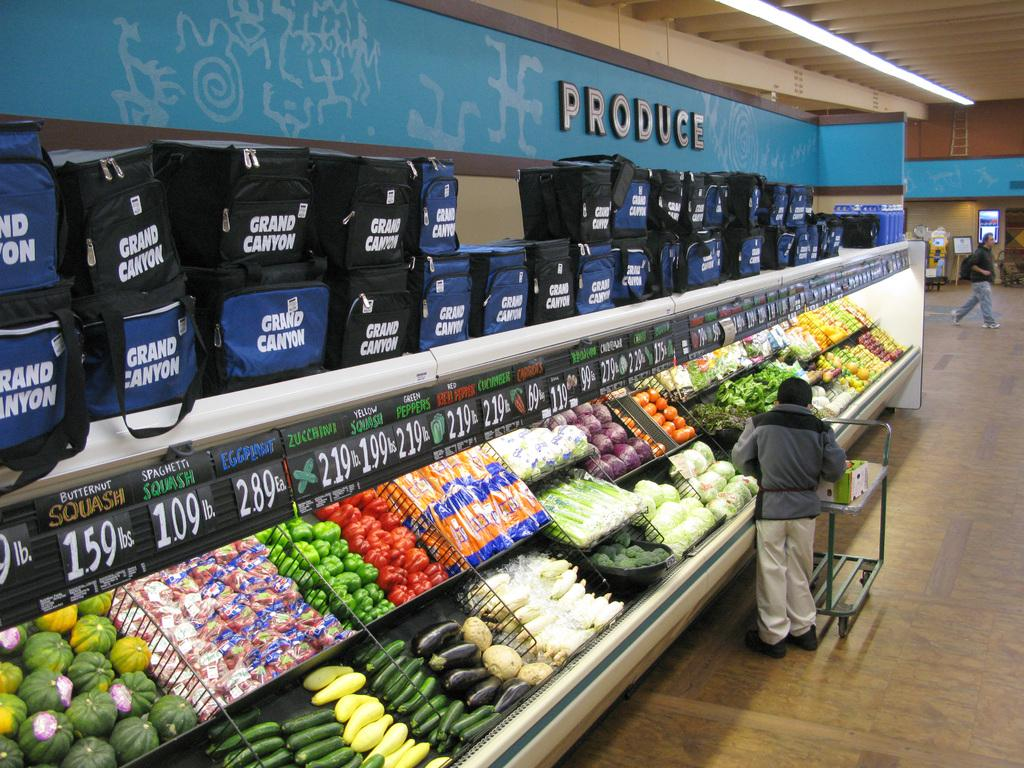<image>
Render a clear and concise summary of the photo. Person shopping for some vegetables under a sign that says Produce. 